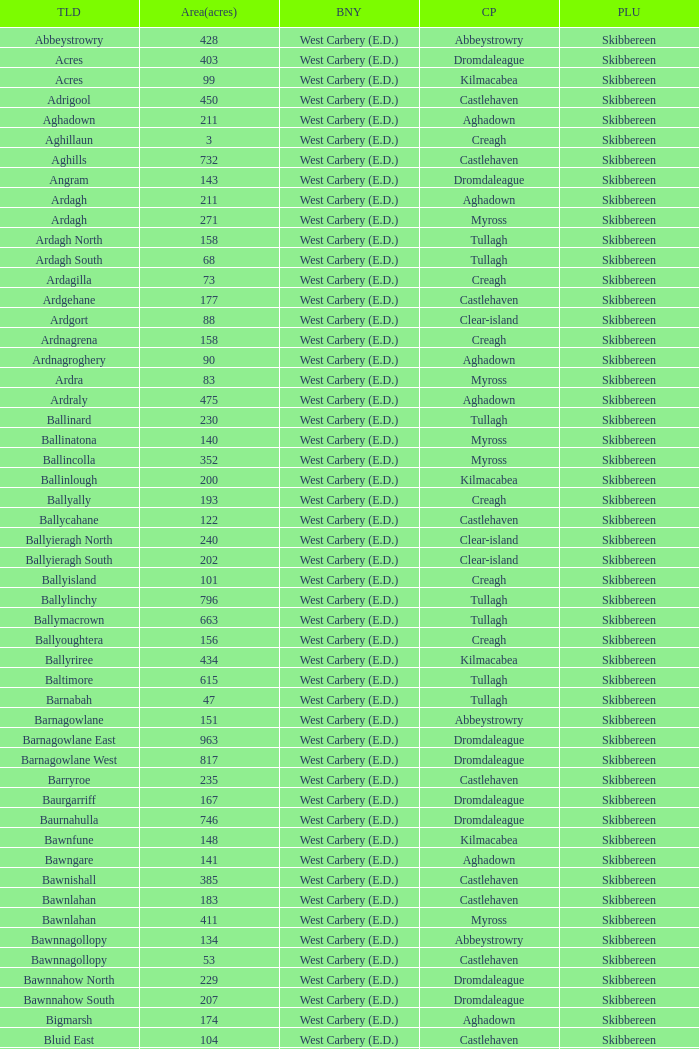What are the civil parishes of the Loughmarsh townland? Aghadown. 